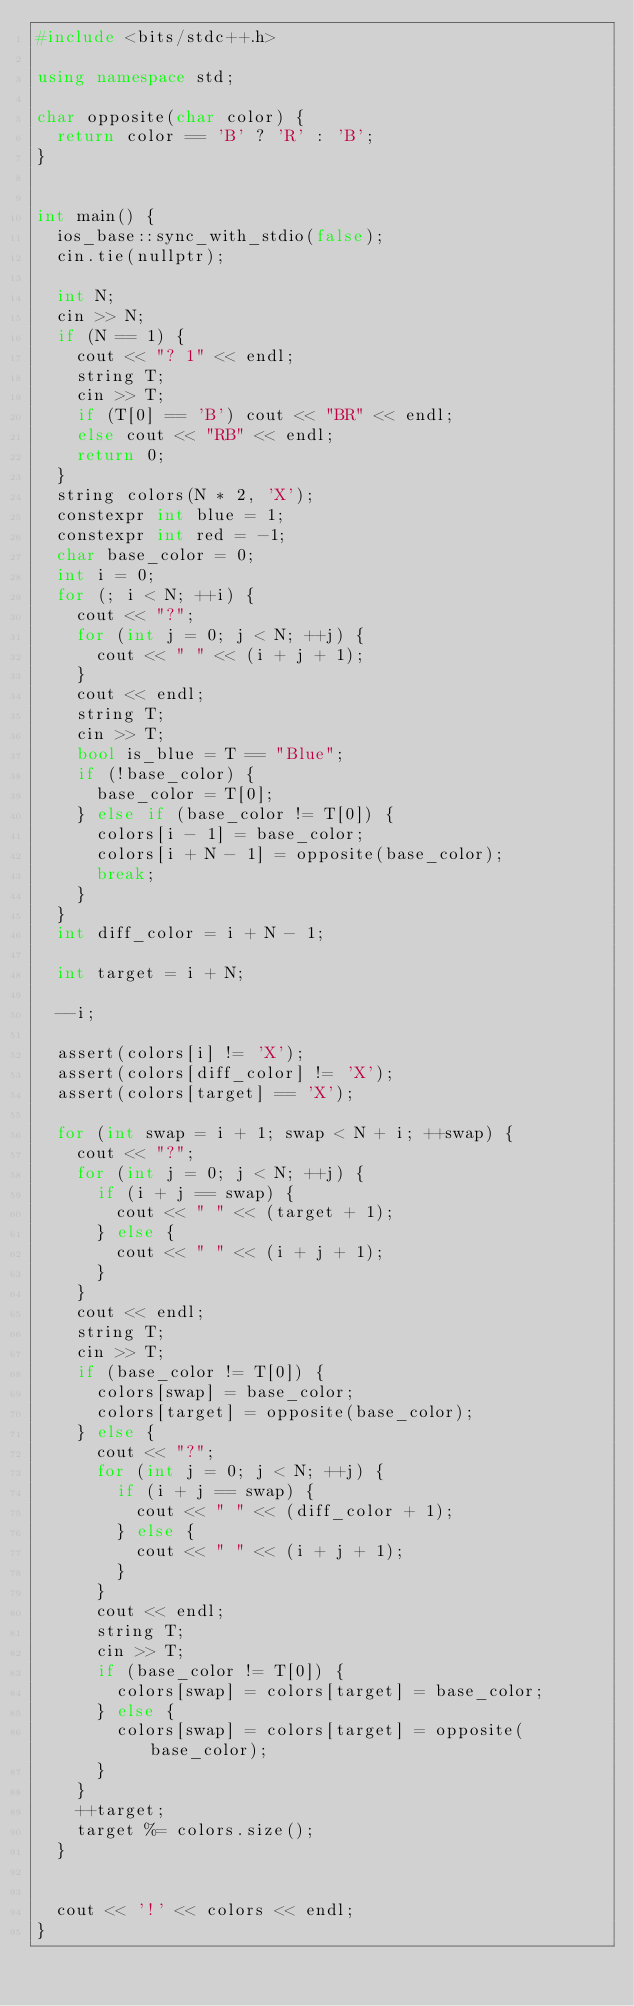Convert code to text. <code><loc_0><loc_0><loc_500><loc_500><_C++_>#include <bits/stdc++.h>

using namespace std;

char opposite(char color) {
  return color == 'B' ? 'R' : 'B';
}


int main() {
  ios_base::sync_with_stdio(false);
  cin.tie(nullptr);

  int N;
  cin >> N;
  if (N == 1) {
    cout << "? 1" << endl;
    string T;
    cin >> T;
    if (T[0] == 'B') cout << "BR" << endl;
    else cout << "RB" << endl;
    return 0;
  }
  string colors(N * 2, 'X');
  constexpr int blue = 1;
  constexpr int red = -1;
  char base_color = 0;
  int i = 0;
  for (; i < N; ++i) {
    cout << "?";
    for (int j = 0; j < N; ++j) {
      cout << " " << (i + j + 1);
    }
    cout << endl;
    string T;
    cin >> T;
    bool is_blue = T == "Blue";
    if (!base_color) {
      base_color = T[0];
    } else if (base_color != T[0]) {
      colors[i - 1] = base_color;
      colors[i + N - 1] = opposite(base_color);
      break;
    }
  }
  int diff_color = i + N - 1;

  int target = i + N;

  --i;

  assert(colors[i] != 'X');
  assert(colors[diff_color] != 'X');
  assert(colors[target] == 'X');

  for (int swap = i + 1; swap < N + i; ++swap) {
    cout << "?";
    for (int j = 0; j < N; ++j) {
      if (i + j == swap) {
        cout << " " << (target + 1);
      } else {
        cout << " " << (i + j + 1);
      }
    }
    cout << endl;
    string T;
    cin >> T;
    if (base_color != T[0]) {
      colors[swap] = base_color;
      colors[target] = opposite(base_color);
    } else {
      cout << "?";
      for (int j = 0; j < N; ++j) {
        if (i + j == swap) {
          cout << " " << (diff_color + 1);
        } else {
          cout << " " << (i + j + 1);
        }
      }
      cout << endl;
      string T;
      cin >> T;
      if (base_color != T[0]) {
        colors[swap] = colors[target] = base_color;
      } else {
        colors[swap] = colors[target] = opposite(base_color);
      }
    }
    ++target;
    target %= colors.size();
  }


  cout << '!' << colors << endl;
}
</code> 